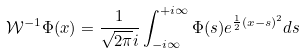<formula> <loc_0><loc_0><loc_500><loc_500>\mathcal { W } ^ { - 1 } \Phi ( x ) = \frac { 1 } { \sqrt { 2 \pi } i } \int _ { - i \infty } ^ { + i \infty } \Phi ( s ) e ^ { \frac { 1 } { 2 } ( x - s ) ^ { 2 } } d s</formula> 